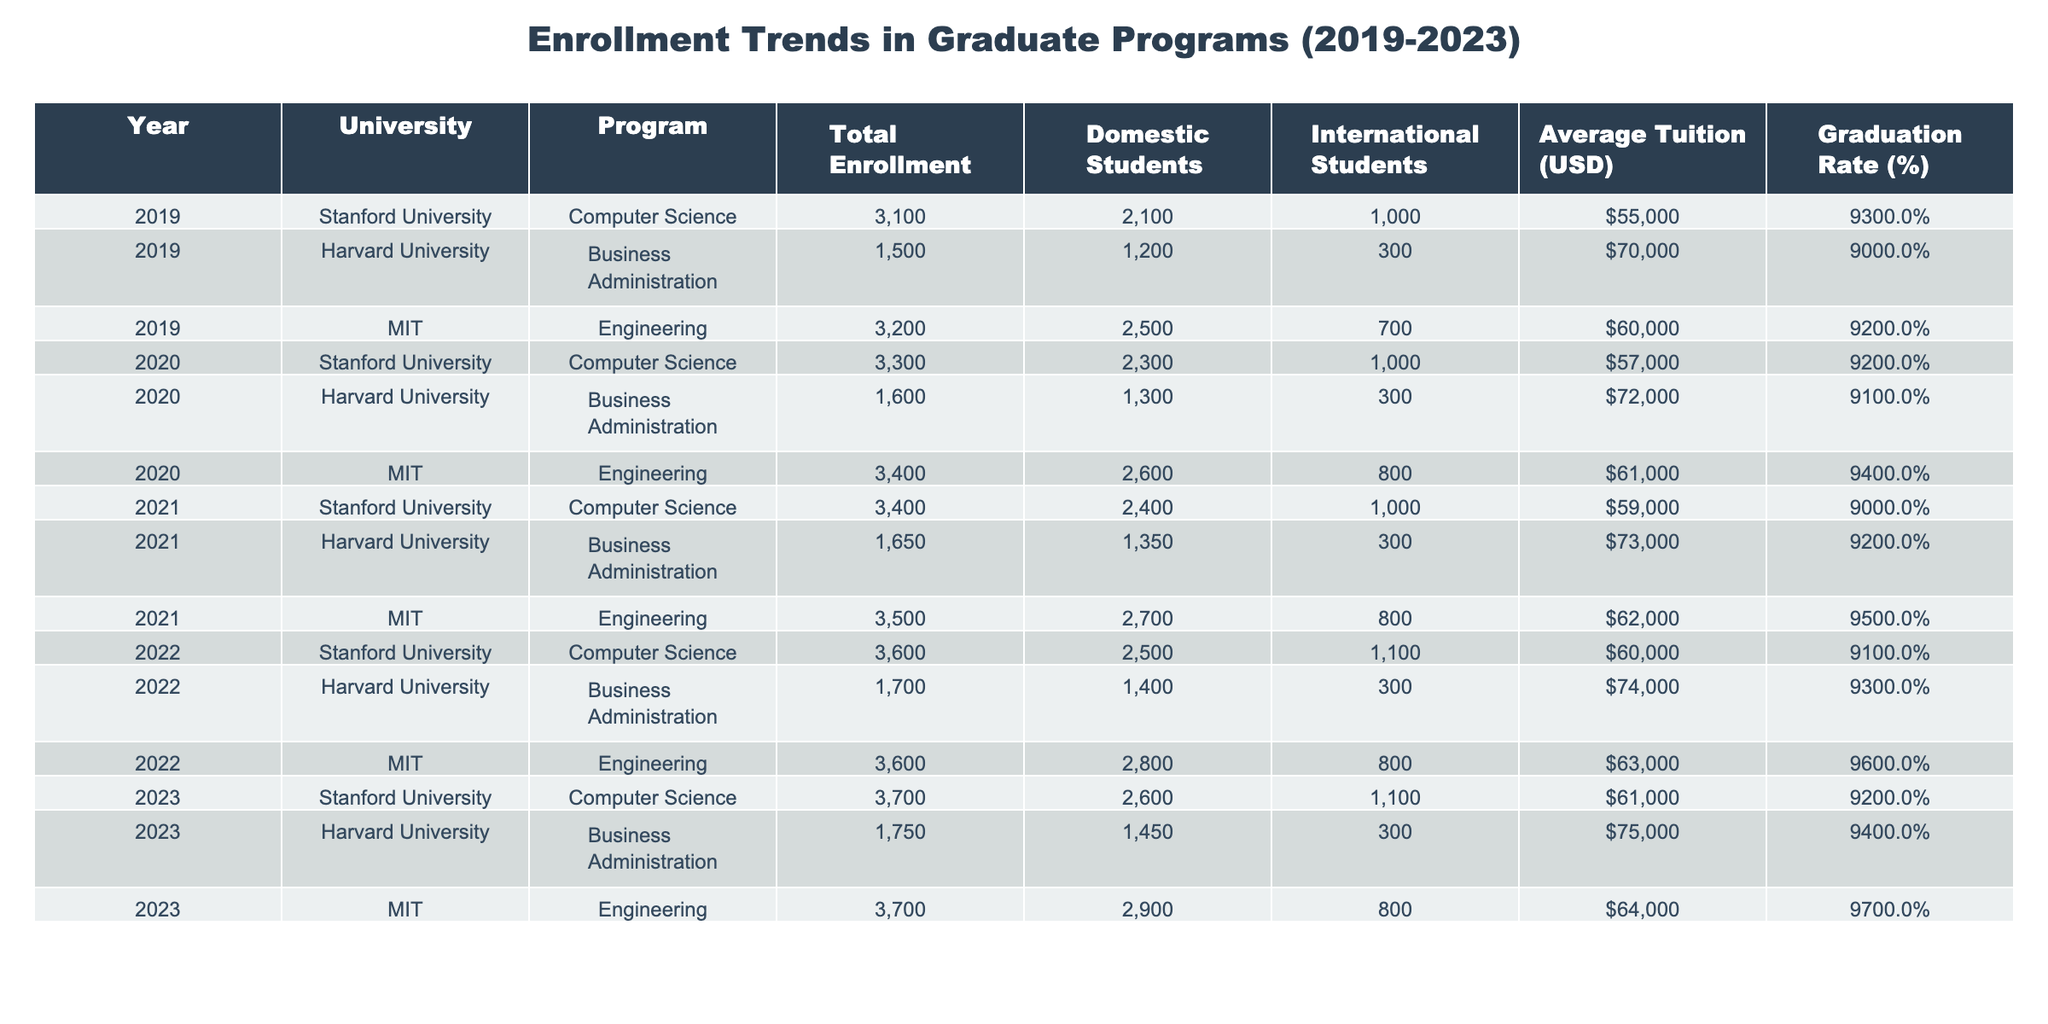What is the total enrollment for MIT in 2022? The table shows the total enrollment for MIT in 2022 as 3600.
Answer: 3600 What was the percentage increase in graduation rate for Harvard's Business Administration program from 2019 to 2023? The graduation rate for Harvard's Business Administration program was 90% in 2019 and increased to 94% in 2023, which is a 4% increase.
Answer: 4% Which program had the highest average tuition in 2023? In 2023, Harvard University's Business Administration program had the highest average tuition at $75,000.
Answer: $75,000 How many more domestic students were enrolled in Stanford University's Computer Science program in 2023 compared to 2019? In 2019, there were 2100 domestic students and in 2023, there were 2600 domestic students in Stanford's Computer Science program, which is an increase of 500 domestic students.
Answer: 500 What is the average tuition for all programs in 2021? The average tuition for 2021 is computed as the sum of the tuition for all programs divided by the number of programs: (59000 + 73000 + 62000) / 3 = $64666.67.
Answer: $64666.67 Did the total enrollment in Computer Science at Stanford increase every year from 2019 to 2023? Checking the total enrollments, it shows a steady increase from 3100 in 2019 to 3700 in 2023, confirming an increase every year.
Answer: Yes Which university had the least number of international students in 2020, and how many were there? In 2020, Harvard University had 300 international students, which is fewer than the international students enrolled at Stanford or MIT that year (1000 and 800, respectively).
Answer: Harvard University, 300 What is the difference in total enrollment between MIT and Stanford in 2023? The total enrollment for MIT in 2023 is 3700, and for Stanford, it is also 3700. Therefore, the difference in total enrollment is 3700 - 3700 = 0.
Answer: 0 What was the total number of domestic students enrolled across all universities in 2022? The total number of domestic students in 2022 is 2500 (Stanford) + 1400 (Harvard) + 2800 (MIT) = 6700.
Answer: 6700 Is the graduation rate for MIT's Engineering program higher than 90% for all years listed? The table shows that the graduation rate for MIT's Engineering program is 92% (2019), 94% (2020), 95% (2021), 96% (2022), and 97% (2023), all of which are higher than 90%.
Answer: Yes 